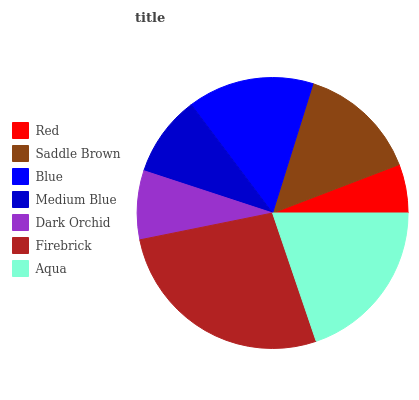Is Red the minimum?
Answer yes or no. Yes. Is Firebrick the maximum?
Answer yes or no. Yes. Is Saddle Brown the minimum?
Answer yes or no. No. Is Saddle Brown the maximum?
Answer yes or no. No. Is Saddle Brown greater than Red?
Answer yes or no. Yes. Is Red less than Saddle Brown?
Answer yes or no. Yes. Is Red greater than Saddle Brown?
Answer yes or no. No. Is Saddle Brown less than Red?
Answer yes or no. No. Is Saddle Brown the high median?
Answer yes or no. Yes. Is Saddle Brown the low median?
Answer yes or no. Yes. Is Red the high median?
Answer yes or no. No. Is Red the low median?
Answer yes or no. No. 